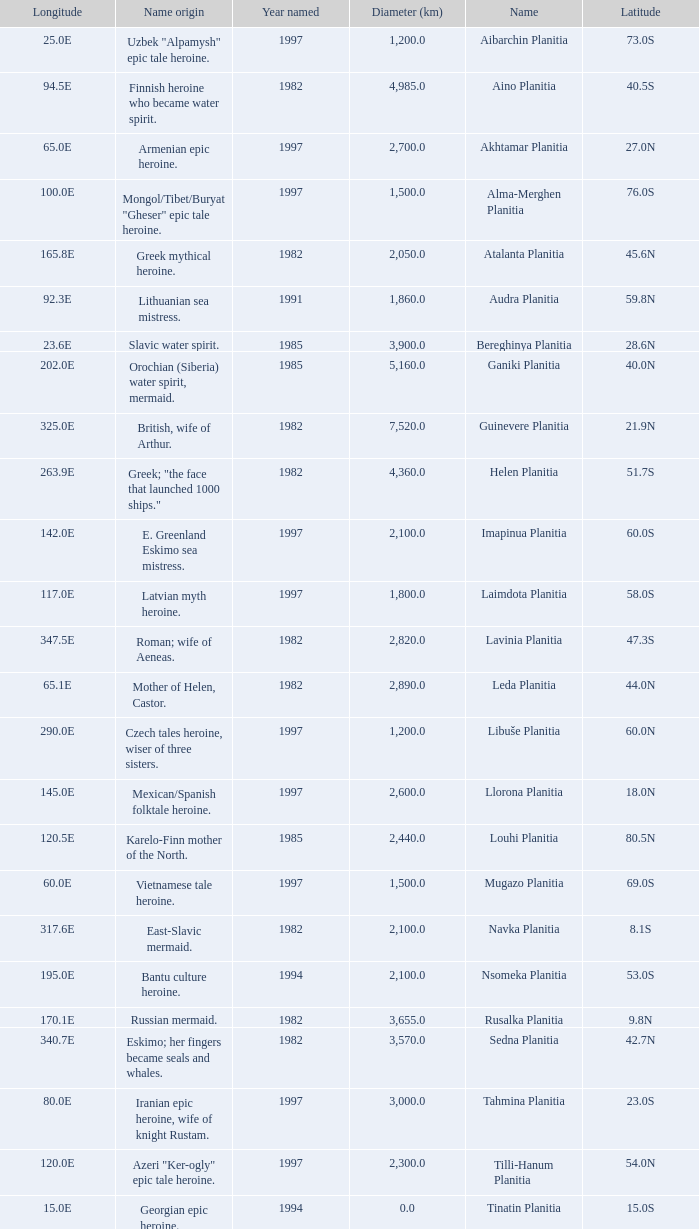What is the latitude of the feature of longitude 80.0e 23.0S. 